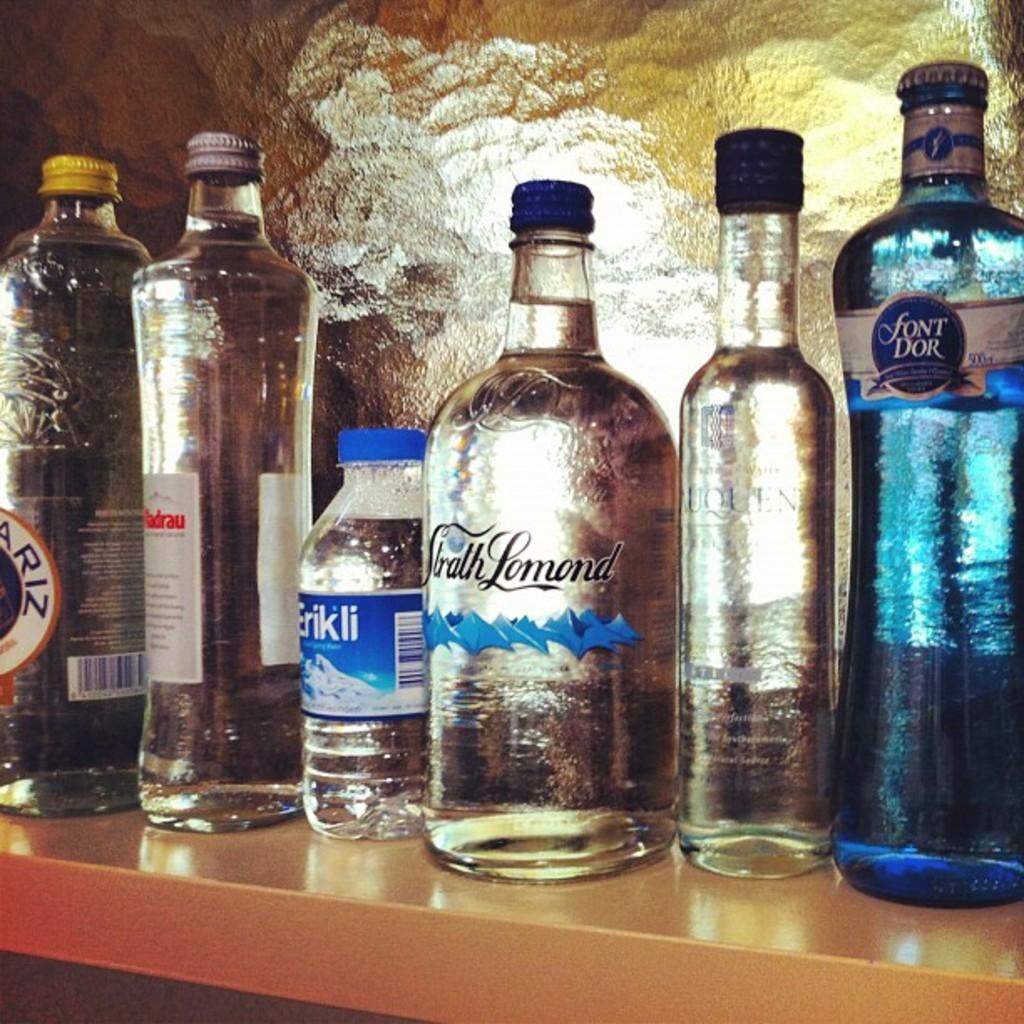In one or two sentences, can you explain what this image depicts? In this picture there are group of bottles with some syrup, label and a lid placed in a rack in an order and the back ground there is a wall. 